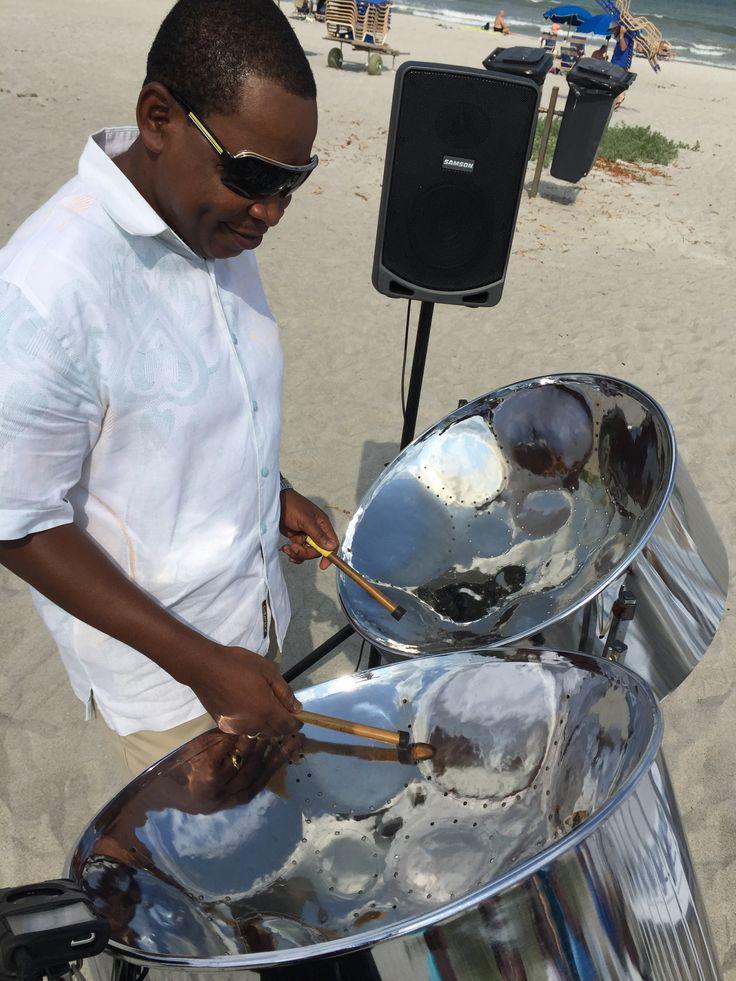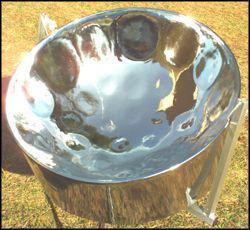The first image is the image on the left, the second image is the image on the right. Assess this claim about the two images: "One of these steel drums is not being played by a human right now.". Correct or not? Answer yes or no. Yes. The first image is the image on the left, the second image is the image on the right. Evaluate the accuracy of this statement regarding the images: "Each image shows a pair of hands holding a pair of drumsticks inside the concave bowl of a silver drum.". Is it true? Answer yes or no. No. 